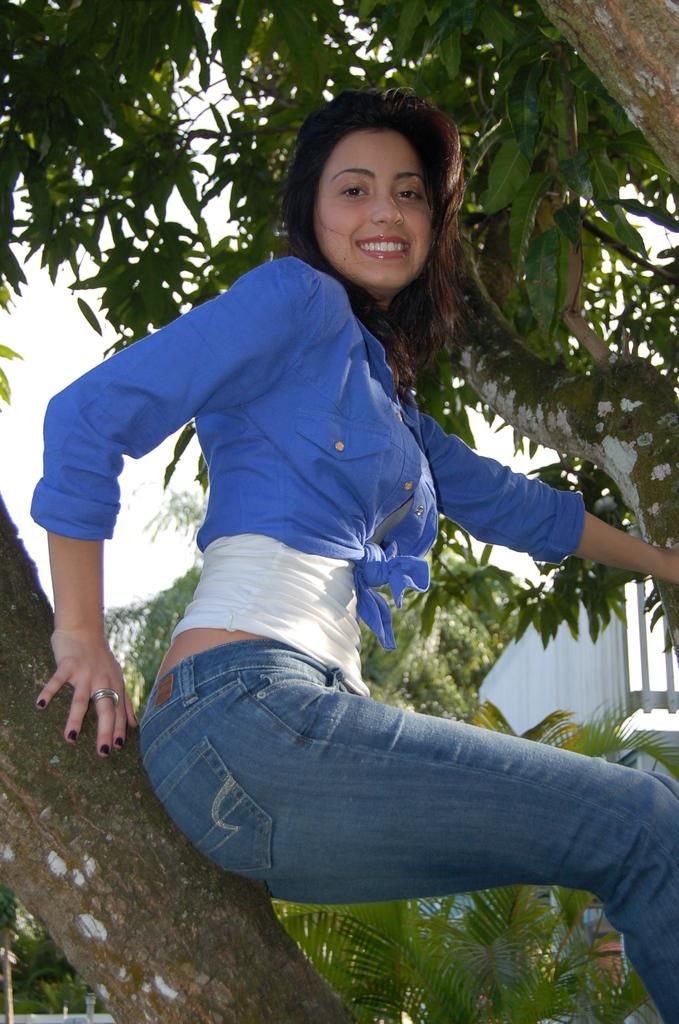Who is present in the image? There is a woman in the image. What is the woman doing in the image? The woman is sitting on a branch. What is the woman's expression in the image? The woman is smiling. What can be seen in the background of the image? There are trees, the sky, a wall, and plants visible in the background of the image. What type of machine is the woman using to practice her religion in the image? There is no machine or religious practice depicted in the image; it features a woman sitting on a branch and smiling. 